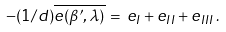Convert formula to latex. <formula><loc_0><loc_0><loc_500><loc_500>- ( 1 / d ) \overline { e ( \beta ^ { \prime } , \lambda ) } \, = \, e _ { I } + e _ { I I } + e _ { I I I } \, .</formula> 